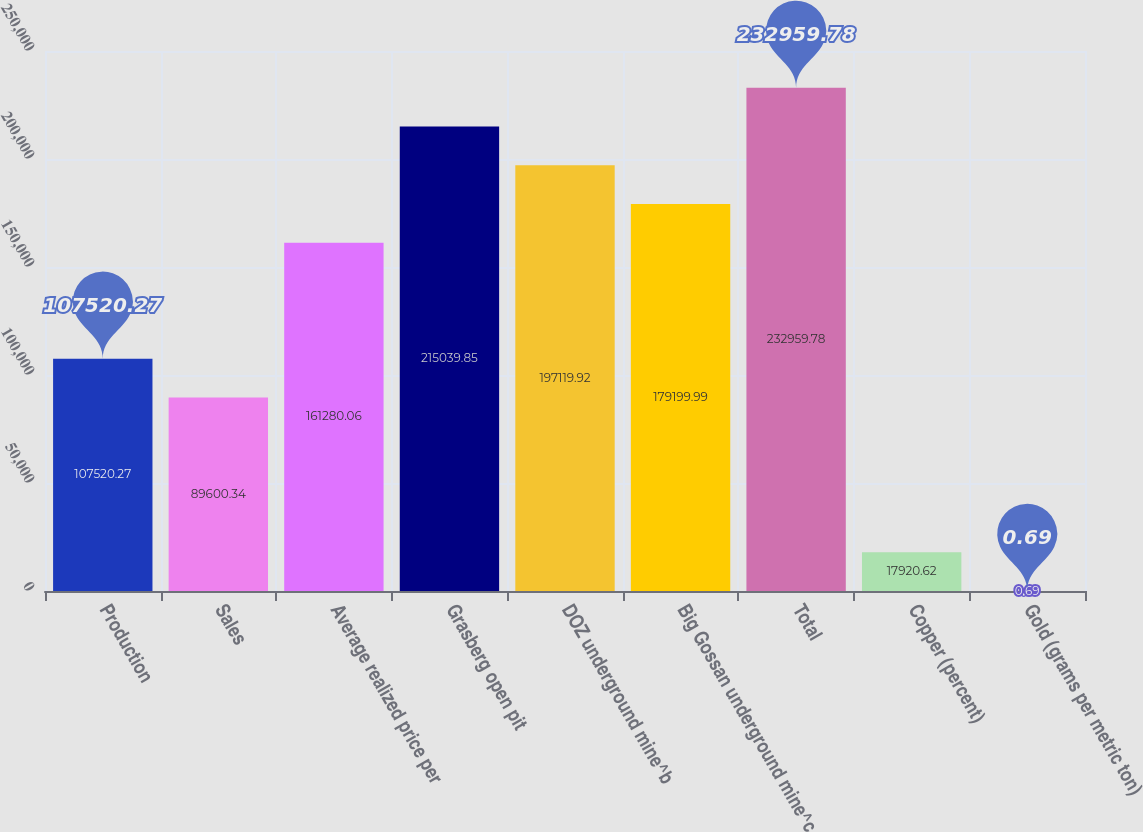<chart> <loc_0><loc_0><loc_500><loc_500><bar_chart><fcel>Production<fcel>Sales<fcel>Average realized price per<fcel>Grasberg open pit<fcel>DOZ underground mine^b<fcel>Big Gossan underground mine^c<fcel>Total<fcel>Copper (percent)<fcel>Gold (grams per metric ton)<nl><fcel>107520<fcel>89600.3<fcel>161280<fcel>215040<fcel>197120<fcel>179200<fcel>232960<fcel>17920.6<fcel>0.69<nl></chart> 